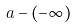Convert formula to latex. <formula><loc_0><loc_0><loc_500><loc_500>a - ( - \infty )</formula> 